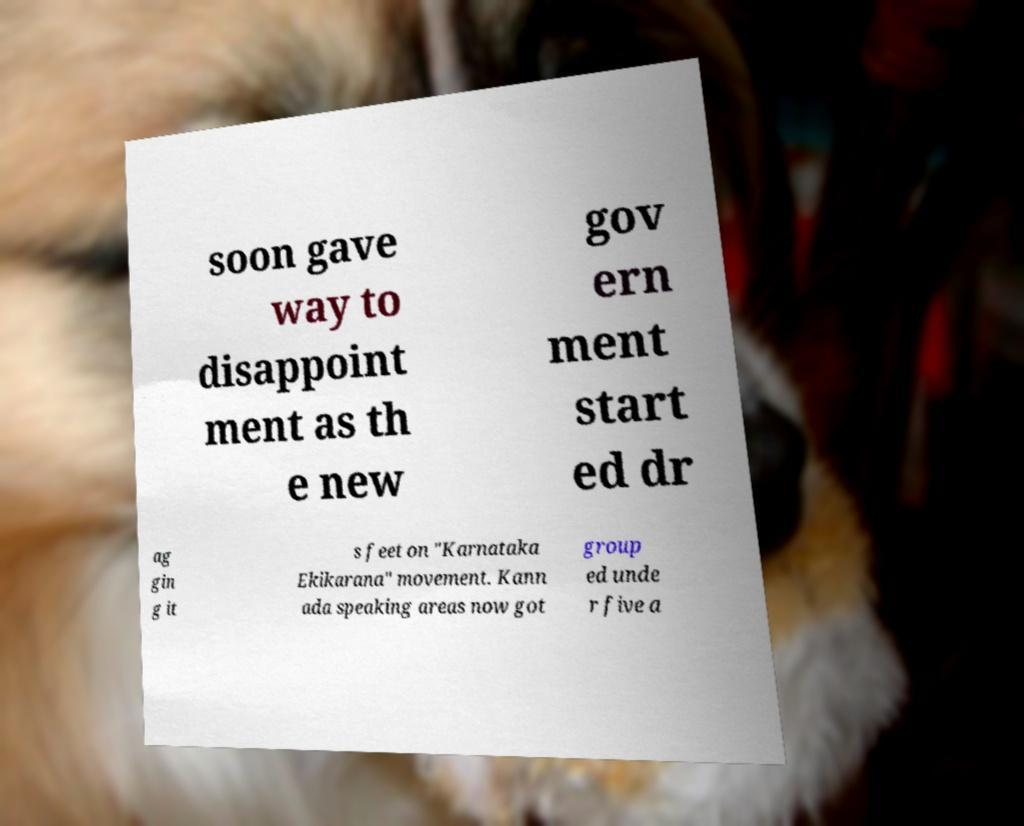What messages or text are displayed in this image? I need them in a readable, typed format. soon gave way to disappoint ment as th e new gov ern ment start ed dr ag gin g it s feet on "Karnataka Ekikarana" movement. Kann ada speaking areas now got group ed unde r five a 